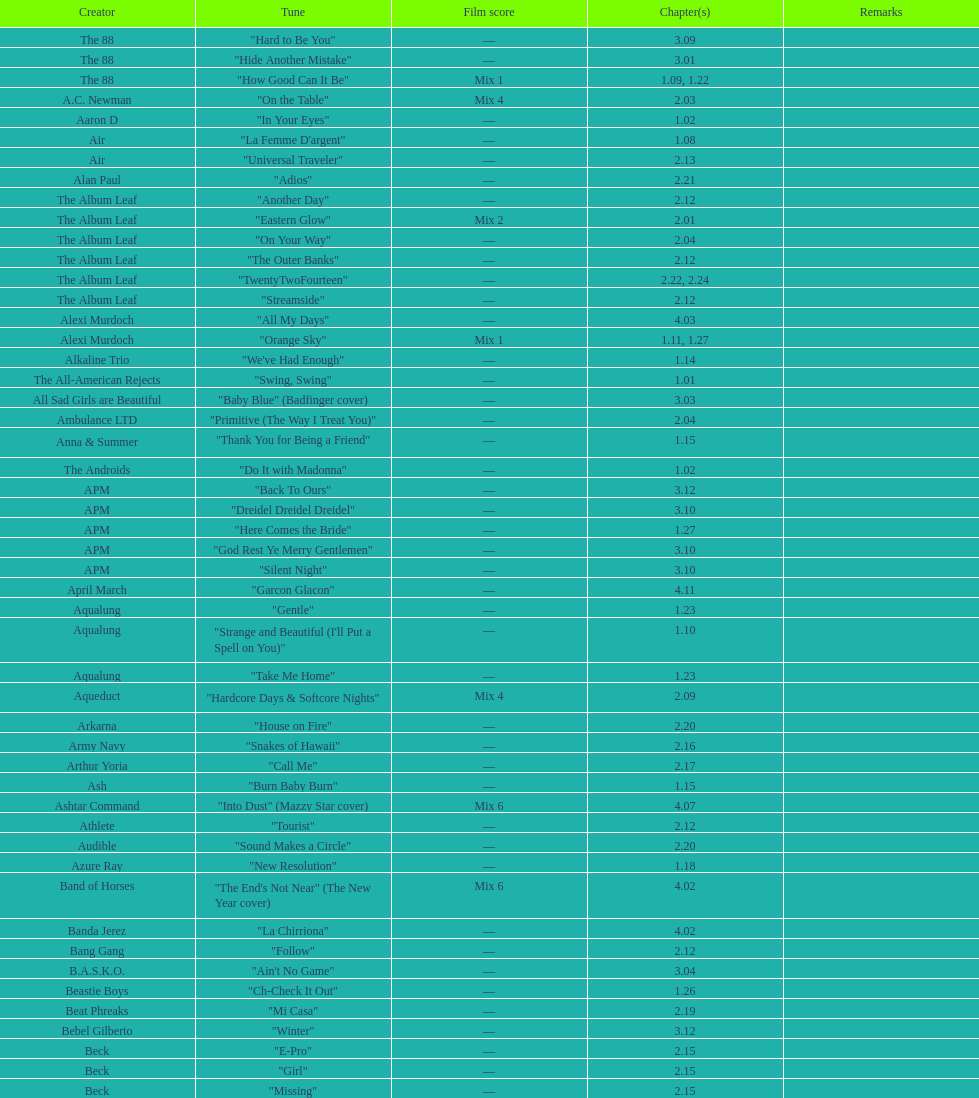The artist ash only had one song that appeared in the o.c. what is the name of that song? "Burn Baby Burn". 